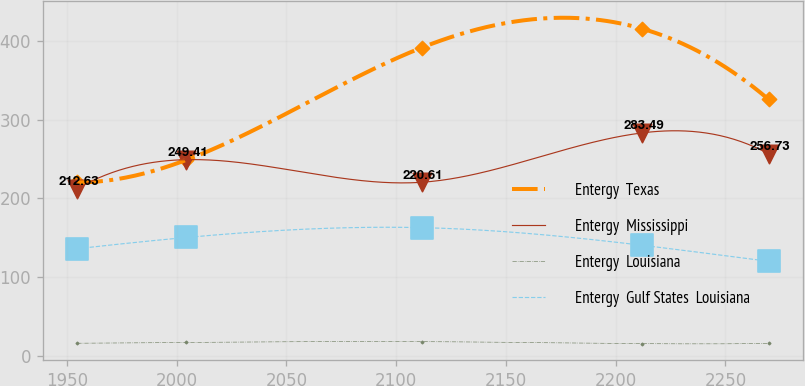Convert chart. <chart><loc_0><loc_0><loc_500><loc_500><line_chart><ecel><fcel>Entergy  Texas<fcel>Entergy  Mississippi<fcel>Entergy  Louisiana<fcel>Entergy  Gulf States  Louisiana<nl><fcel>1954.79<fcel>220.49<fcel>212.63<fcel>15.76<fcel>136.13<nl><fcel>2004.41<fcel>249.01<fcel>249.41<fcel>16.77<fcel>150.37<nl><fcel>2111.57<fcel>391.84<fcel>220.61<fcel>17.83<fcel>162.89<nl><fcel>2212.16<fcel>415.97<fcel>283.49<fcel>15.24<fcel>140.41<nl><fcel>2269.71<fcel>325.99<fcel>256.73<fcel>15.5<fcel>120.05<nl></chart> 